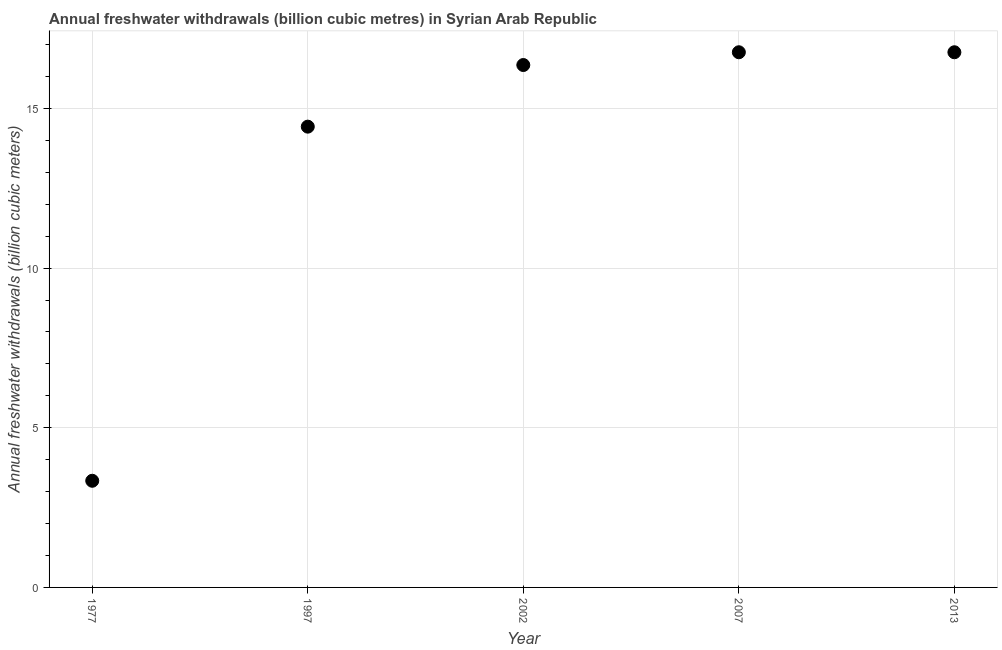What is the annual freshwater withdrawals in 1997?
Keep it short and to the point. 14.43. Across all years, what is the maximum annual freshwater withdrawals?
Keep it short and to the point. 16.76. Across all years, what is the minimum annual freshwater withdrawals?
Offer a terse response. 3.34. In which year was the annual freshwater withdrawals maximum?
Keep it short and to the point. 2007. In which year was the annual freshwater withdrawals minimum?
Give a very brief answer. 1977. What is the sum of the annual freshwater withdrawals?
Ensure brevity in your answer.  67.65. What is the difference between the annual freshwater withdrawals in 1977 and 1997?
Provide a succinct answer. -11.09. What is the average annual freshwater withdrawals per year?
Give a very brief answer. 13.53. What is the median annual freshwater withdrawals?
Keep it short and to the point. 16.36. What is the ratio of the annual freshwater withdrawals in 2002 to that in 2013?
Give a very brief answer. 0.98. Is the annual freshwater withdrawals in 2007 less than that in 2013?
Your answer should be compact. No. Is the difference between the annual freshwater withdrawals in 2002 and 2013 greater than the difference between any two years?
Ensure brevity in your answer.  No. What is the difference between the highest and the lowest annual freshwater withdrawals?
Offer a terse response. 13.42. In how many years, is the annual freshwater withdrawals greater than the average annual freshwater withdrawals taken over all years?
Give a very brief answer. 4. Does the annual freshwater withdrawals monotonically increase over the years?
Your response must be concise. No. How many dotlines are there?
Ensure brevity in your answer.  1. How many years are there in the graph?
Provide a short and direct response. 5. Are the values on the major ticks of Y-axis written in scientific E-notation?
Provide a short and direct response. No. Does the graph contain any zero values?
Keep it short and to the point. No. What is the title of the graph?
Keep it short and to the point. Annual freshwater withdrawals (billion cubic metres) in Syrian Arab Republic. What is the label or title of the X-axis?
Give a very brief answer. Year. What is the label or title of the Y-axis?
Give a very brief answer. Annual freshwater withdrawals (billion cubic meters). What is the Annual freshwater withdrawals (billion cubic meters) in 1977?
Ensure brevity in your answer.  3.34. What is the Annual freshwater withdrawals (billion cubic meters) in 1997?
Provide a short and direct response. 14.43. What is the Annual freshwater withdrawals (billion cubic meters) in 2002?
Keep it short and to the point. 16.36. What is the Annual freshwater withdrawals (billion cubic meters) in 2007?
Your answer should be very brief. 16.76. What is the Annual freshwater withdrawals (billion cubic meters) in 2013?
Your response must be concise. 16.76. What is the difference between the Annual freshwater withdrawals (billion cubic meters) in 1977 and 1997?
Offer a terse response. -11.09. What is the difference between the Annual freshwater withdrawals (billion cubic meters) in 1977 and 2002?
Make the answer very short. -13.02. What is the difference between the Annual freshwater withdrawals (billion cubic meters) in 1977 and 2007?
Your answer should be compact. -13.42. What is the difference between the Annual freshwater withdrawals (billion cubic meters) in 1977 and 2013?
Give a very brief answer. -13.42. What is the difference between the Annual freshwater withdrawals (billion cubic meters) in 1997 and 2002?
Ensure brevity in your answer.  -1.93. What is the difference between the Annual freshwater withdrawals (billion cubic meters) in 1997 and 2007?
Your answer should be very brief. -2.33. What is the difference between the Annual freshwater withdrawals (billion cubic meters) in 1997 and 2013?
Offer a terse response. -2.33. What is the difference between the Annual freshwater withdrawals (billion cubic meters) in 2002 and 2007?
Make the answer very short. -0.4. What is the difference between the Annual freshwater withdrawals (billion cubic meters) in 2002 and 2013?
Ensure brevity in your answer.  -0.4. What is the difference between the Annual freshwater withdrawals (billion cubic meters) in 2007 and 2013?
Make the answer very short. 0. What is the ratio of the Annual freshwater withdrawals (billion cubic meters) in 1977 to that in 1997?
Provide a short and direct response. 0.23. What is the ratio of the Annual freshwater withdrawals (billion cubic meters) in 1977 to that in 2002?
Your answer should be compact. 0.2. What is the ratio of the Annual freshwater withdrawals (billion cubic meters) in 1977 to that in 2007?
Provide a succinct answer. 0.2. What is the ratio of the Annual freshwater withdrawals (billion cubic meters) in 1977 to that in 2013?
Your response must be concise. 0.2. What is the ratio of the Annual freshwater withdrawals (billion cubic meters) in 1997 to that in 2002?
Keep it short and to the point. 0.88. What is the ratio of the Annual freshwater withdrawals (billion cubic meters) in 1997 to that in 2007?
Your answer should be very brief. 0.86. What is the ratio of the Annual freshwater withdrawals (billion cubic meters) in 1997 to that in 2013?
Offer a terse response. 0.86. What is the ratio of the Annual freshwater withdrawals (billion cubic meters) in 2007 to that in 2013?
Offer a terse response. 1. 